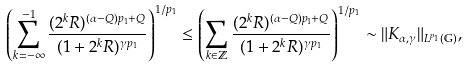<formula> <loc_0><loc_0><loc_500><loc_500>\left ( \sum _ { k = - \infty } ^ { - 1 } \frac { ( 2 ^ { k } R ) ^ { ( \alpha - Q ) p _ { 1 } + Q } } { ( 1 + 2 ^ { k } R ) ^ { \gamma p _ { 1 } } } \right ) ^ { 1 / p _ { 1 } } \leq \left ( \sum _ { k \in \mathbb { Z } } \frac { ( 2 ^ { k } R ) ^ { ( \alpha - Q ) p _ { 1 } + Q } } { ( 1 + 2 ^ { k } R ) ^ { \gamma p _ { 1 } } } \right ) ^ { 1 / p _ { 1 } } \sim \| K _ { \alpha , \gamma } \| _ { L ^ { p _ { 1 } } ( \mathbb { G } ) } ,</formula> 